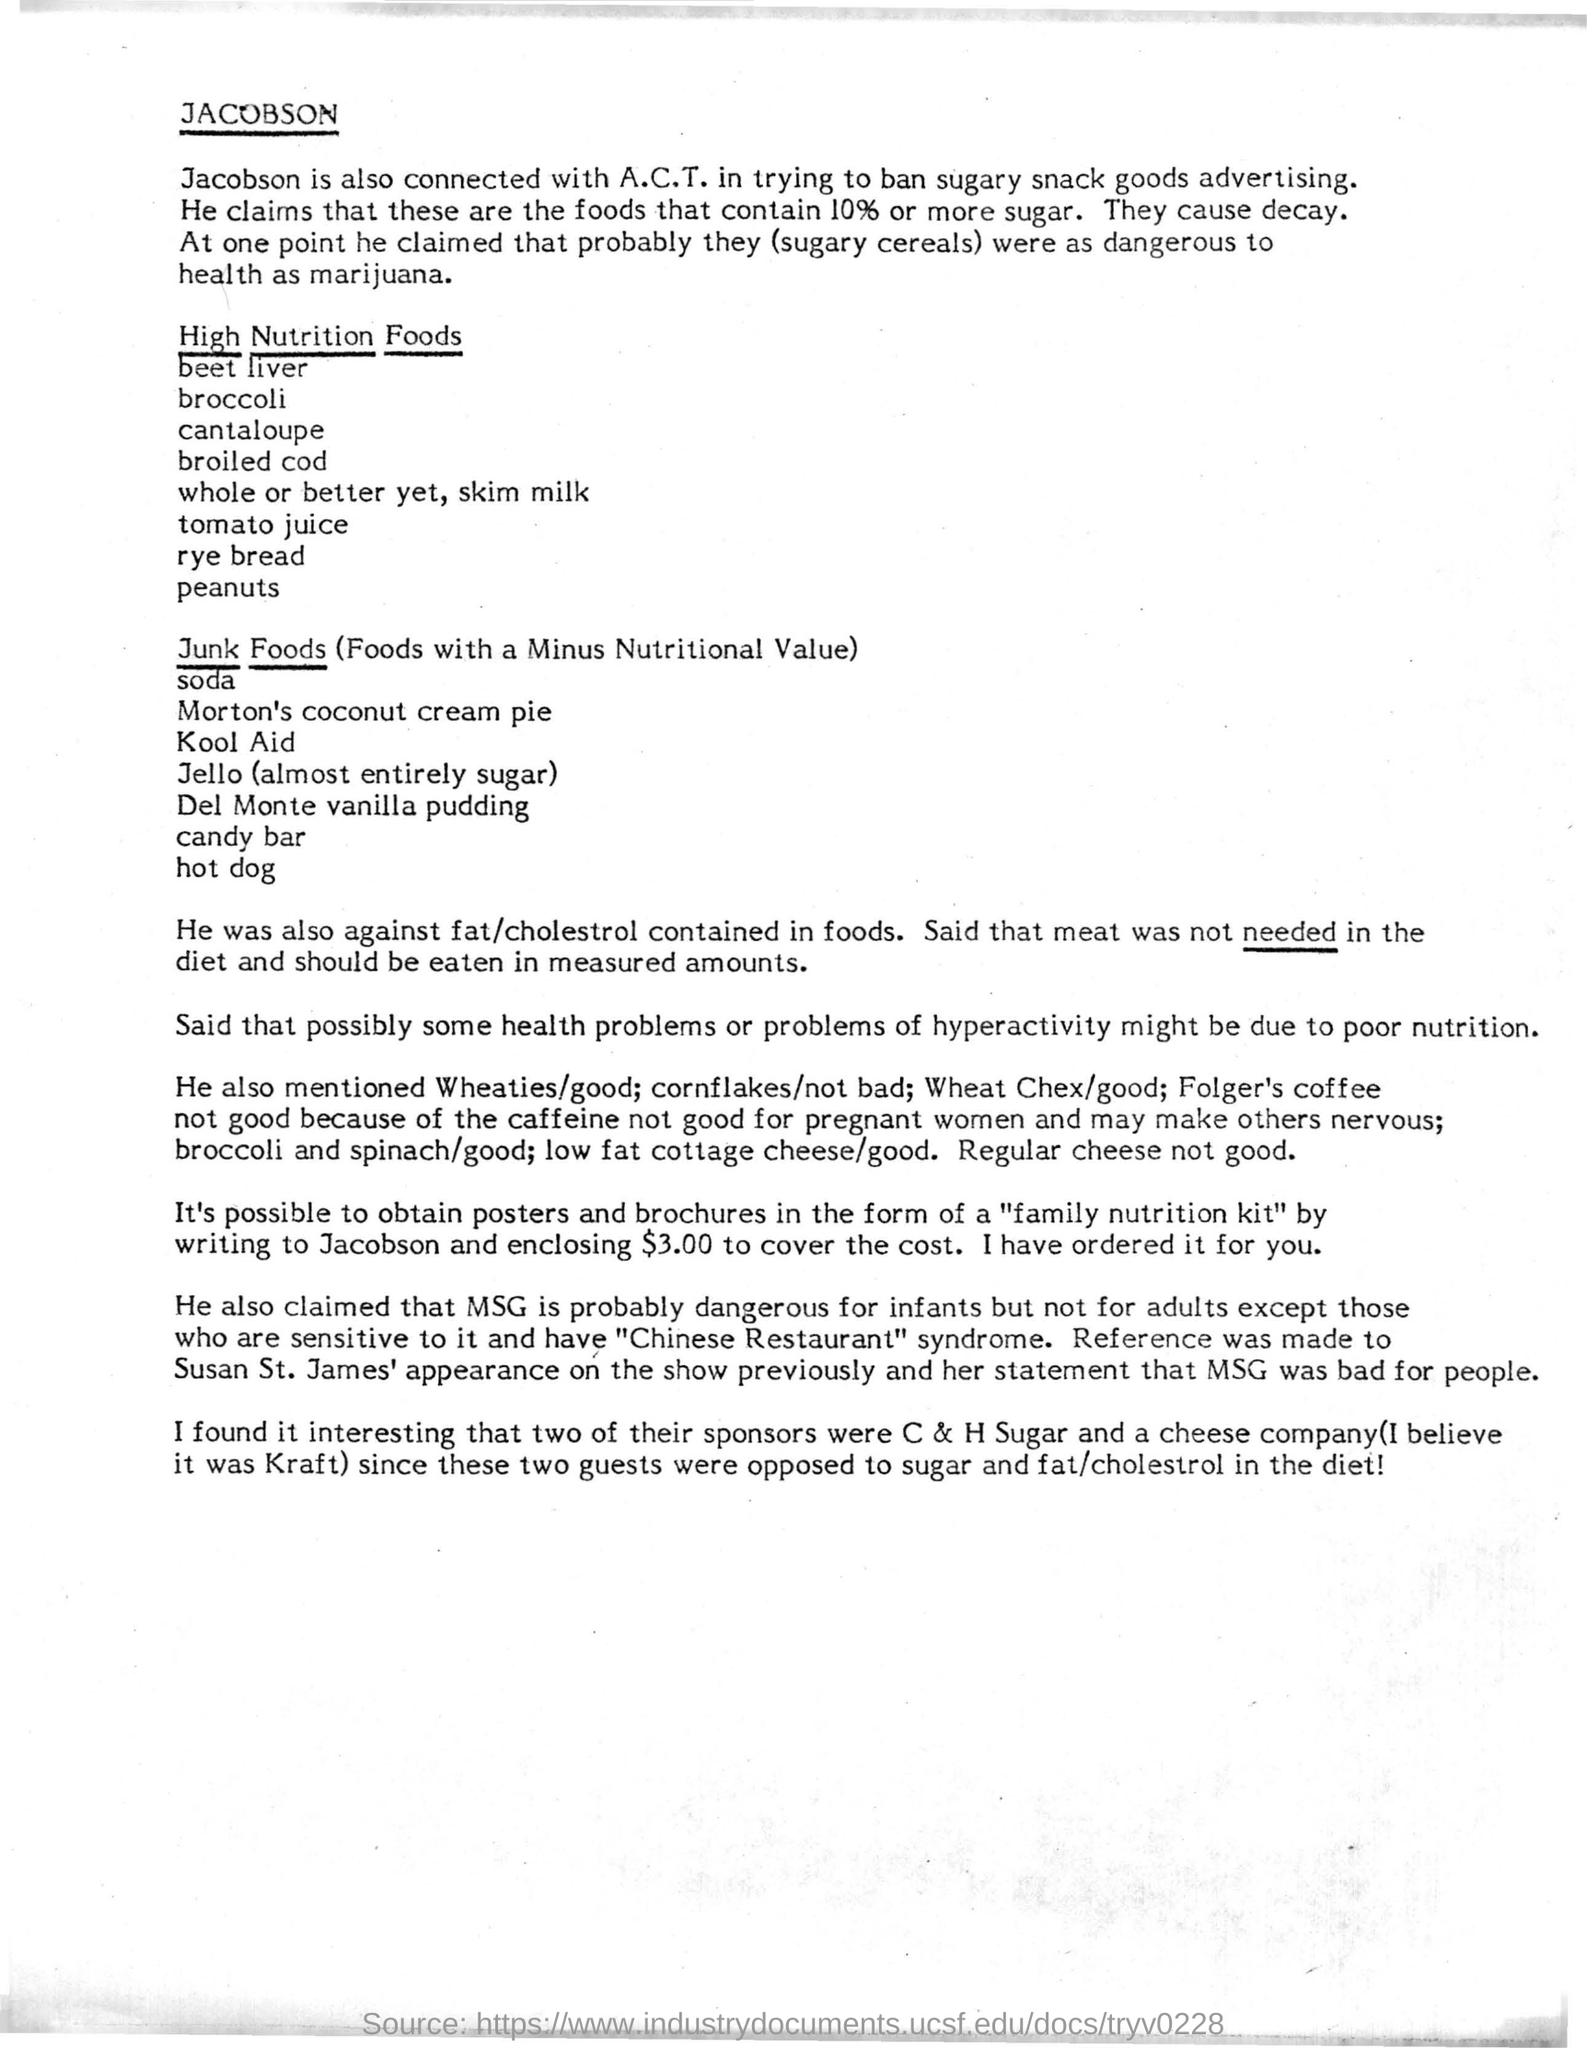Point out several critical features in this image. Jacobson is connected with A.C.T in their efforts to ban the advertising of sugary snack goods. 